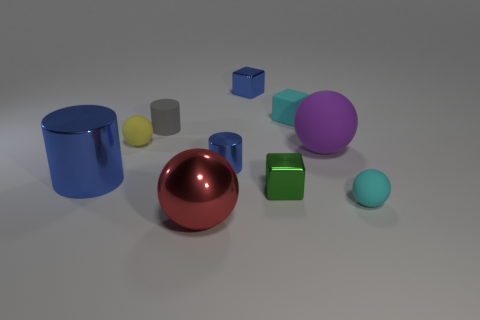What is the shape of the small metal object that is behind the small blue object that is in front of the yellow rubber object?
Make the answer very short. Cube. There is a small rubber thing that is on the right side of the big purple rubber ball; is it the same color as the tiny cylinder that is to the left of the big red shiny thing?
Keep it short and to the point. No. Are there any other things that are the same color as the large metal cylinder?
Your answer should be very brief. Yes. What color is the big metal cylinder?
Make the answer very short. Blue. Is there a yellow metal cylinder?
Provide a short and direct response. No. Are there any big metallic things on the right side of the large cylinder?
Make the answer very short. Yes. What is the material of the purple thing that is the same shape as the red metallic thing?
Your response must be concise. Rubber. Is there any other thing that has the same material as the small gray object?
Make the answer very short. Yes. How many other objects are there of the same shape as the red thing?
Provide a succinct answer. 3. What number of small yellow balls are on the right side of the blue metal cylinder that is on the right side of the large shiny object that is on the right side of the yellow object?
Your response must be concise. 0. 